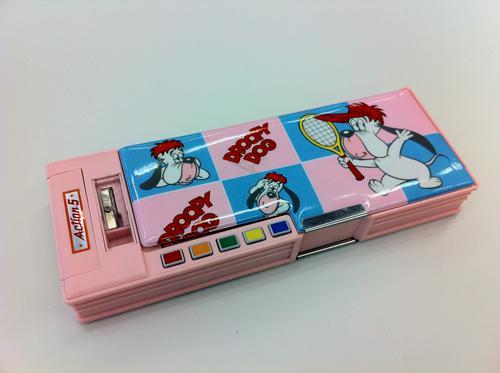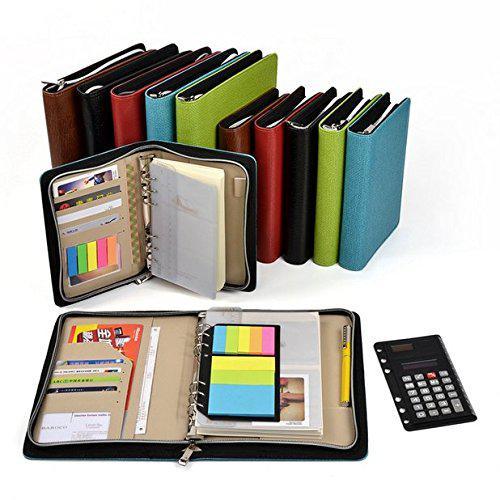The first image is the image on the left, the second image is the image on the right. Considering the images on both sides, is "Only pencil cases with zipper closures are shown, at least one case is hot pink, one case is closed, and at least one case is open." valid? Answer yes or no. No. The first image is the image on the left, the second image is the image on the right. For the images displayed, is the sentence "Exactly one bag is closed." factually correct? Answer yes or no. No. 